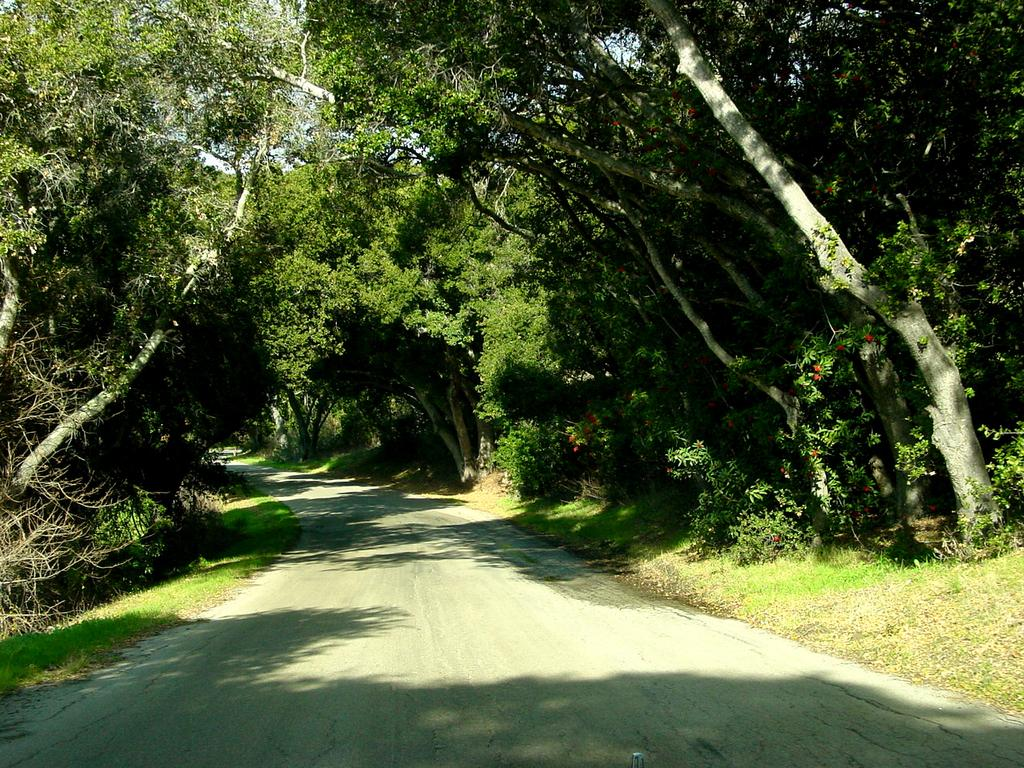What is the main feature of the image? There is a road in the image. What can be seen alongside the road? Trees and grass are visible alongside the road. What type of machine is the queen using to exchange her crown in the image? There is no queen, machine, or crown present in the image. 